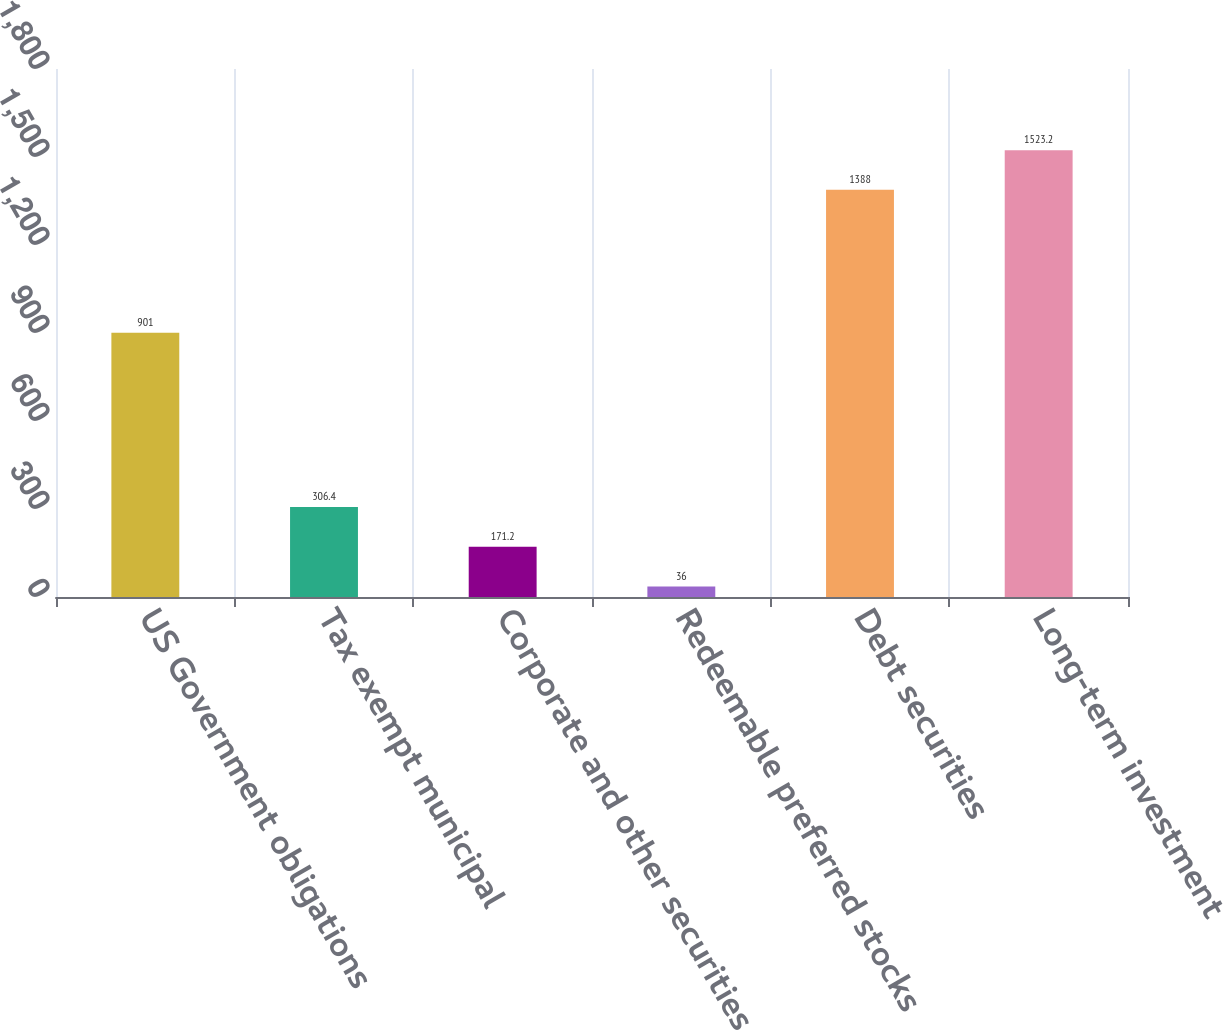Convert chart to OTSL. <chart><loc_0><loc_0><loc_500><loc_500><bar_chart><fcel>US Government obligations<fcel>Tax exempt municipal<fcel>Corporate and other securities<fcel>Redeemable preferred stocks<fcel>Debt securities<fcel>Long-term investment<nl><fcel>901<fcel>306.4<fcel>171.2<fcel>36<fcel>1388<fcel>1523.2<nl></chart> 